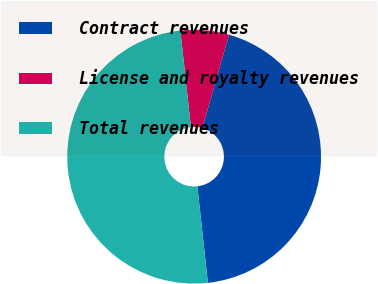<chart> <loc_0><loc_0><loc_500><loc_500><pie_chart><fcel>Contract revenues<fcel>License and royalty revenues<fcel>Total revenues<nl><fcel>43.84%<fcel>6.16%<fcel>50.0%<nl></chart> 